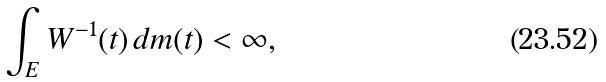Convert formula to latex. <formula><loc_0><loc_0><loc_500><loc_500>\int _ { E } W ^ { - 1 } ( t ) \, d m ( t ) < \infty ,</formula> 